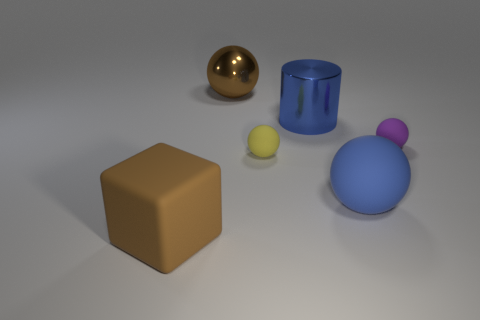Subtract 1 balls. How many balls are left? 3 Add 3 purple rubber spheres. How many objects exist? 9 Subtract all cylinders. How many objects are left? 5 Add 3 large blue things. How many large blue things are left? 5 Add 5 tiny purple spheres. How many tiny purple spheres exist? 6 Subtract 0 yellow cubes. How many objects are left? 6 Subtract all rubber objects. Subtract all big blocks. How many objects are left? 1 